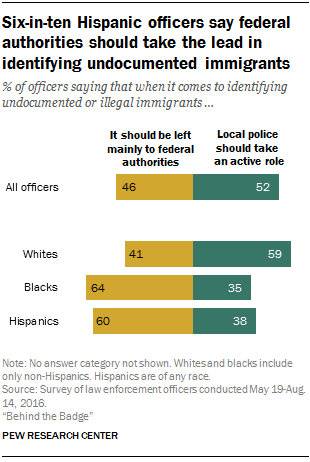Indicate a few pertinent items in this graphic. The value of the second yellow bar from the top is 41. The total sum of all yellow bars above 50 is 124. 